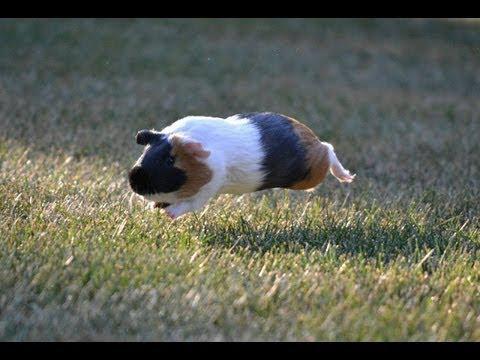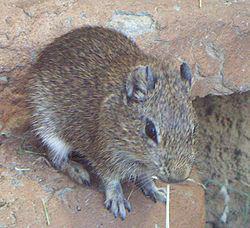The first image is the image on the left, the second image is the image on the right. Considering the images on both sides, is "An image shows one guinea pig standing in green grass." valid? Answer yes or no. No. The first image is the image on the left, the second image is the image on the right. Examine the images to the left and right. Is the description "One of the rodents is sitting still in the green grass." accurate? Answer yes or no. No. 